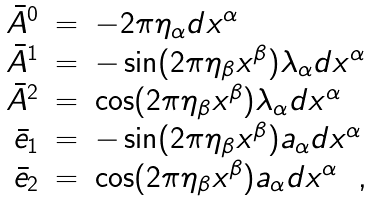<formula> <loc_0><loc_0><loc_500><loc_500>\begin{array} { r c l } { \bar { A } } ^ { 0 } & = & - 2 \pi \eta _ { \alpha } d x ^ { \alpha } \\ { \bar { A } } ^ { 1 } & = & - \sin ( 2 \pi \eta _ { \beta } x ^ { \beta } ) \lambda _ { \alpha } d x ^ { \alpha } \\ { \bar { A } } ^ { 2 } & = & \cos ( 2 \pi \eta _ { \beta } x ^ { \beta } ) \lambda _ { \alpha } d x ^ { \alpha } \\ { \bar { e } } _ { 1 } & = & - \sin ( 2 \pi \eta _ { \beta } x ^ { \beta } ) a _ { \alpha } d x ^ { \alpha } \\ { \bar { e } } _ { 2 } & = & \cos ( 2 \pi \eta _ { \beta } x ^ { \beta } ) a _ { \alpha } d x ^ { \alpha } \ \ , \end{array}</formula> 